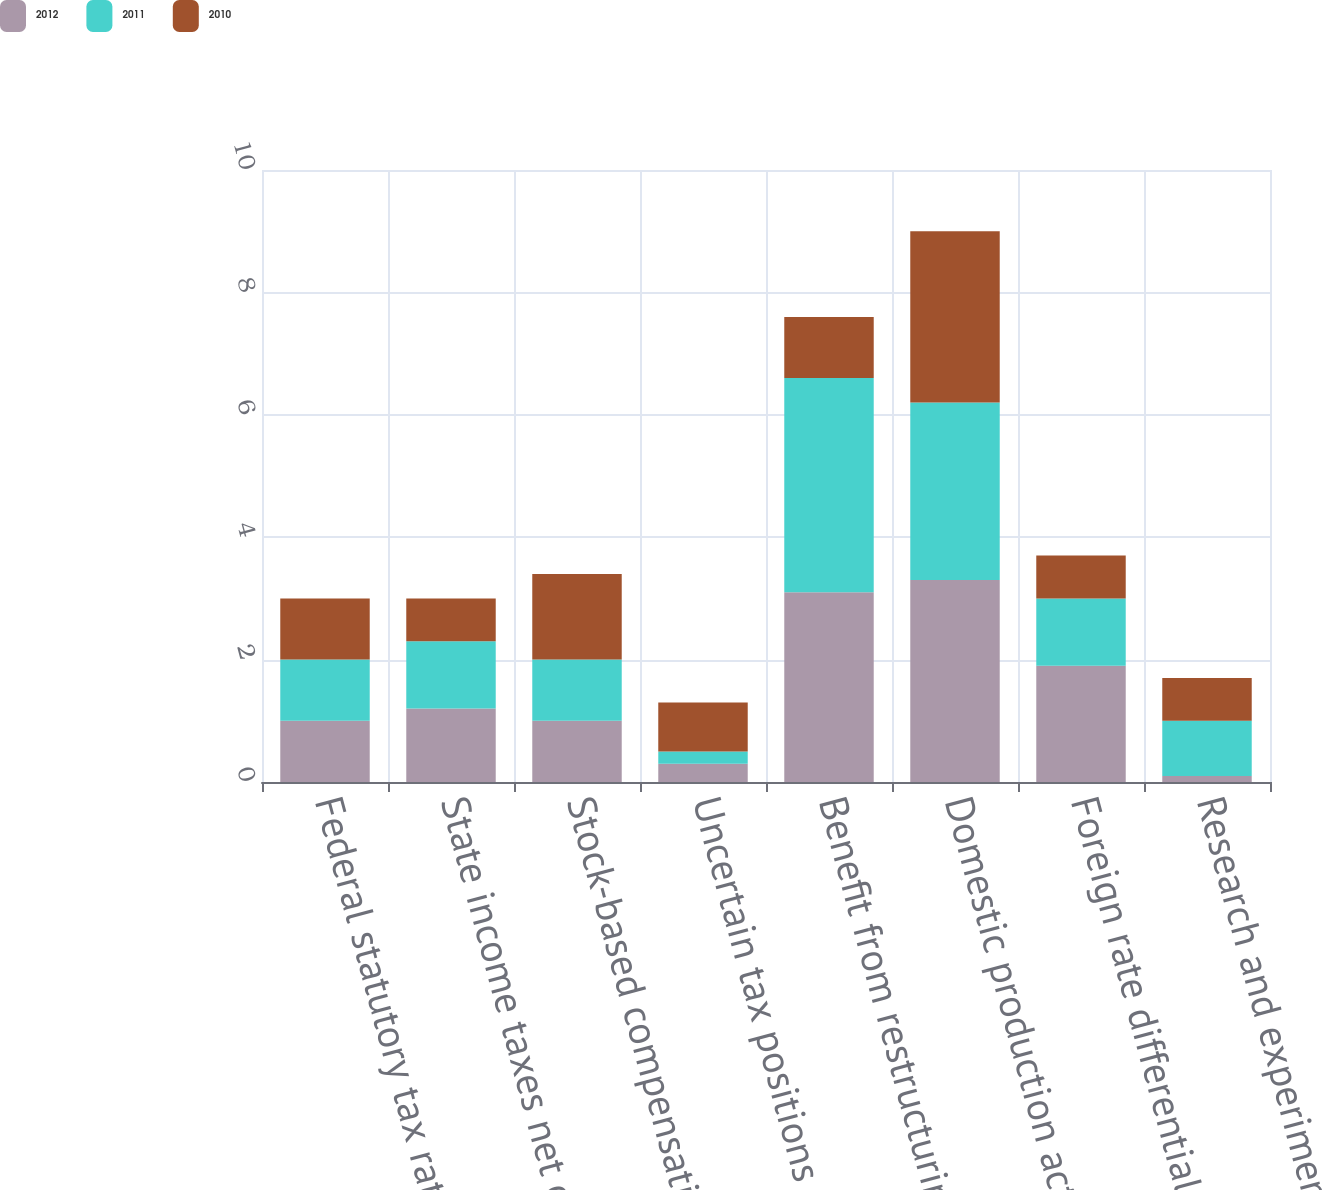<chart> <loc_0><loc_0><loc_500><loc_500><stacked_bar_chart><ecel><fcel>Federal statutory tax rate<fcel>State income taxes net of<fcel>Stock-based compensation<fcel>Uncertain tax positions<fcel>Benefit from restructuring<fcel>Domestic production activity<fcel>Foreign rate differential<fcel>Research and experimentation<nl><fcel>2012<fcel>1<fcel>1.2<fcel>1<fcel>0.3<fcel>3.1<fcel>3.3<fcel>1.9<fcel>0.1<nl><fcel>2011<fcel>1<fcel>1.1<fcel>1<fcel>0.2<fcel>3.5<fcel>2.9<fcel>1.1<fcel>0.9<nl><fcel>2010<fcel>1<fcel>0.7<fcel>1.4<fcel>0.8<fcel>1<fcel>2.8<fcel>0.7<fcel>0.7<nl></chart> 